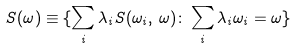Convert formula to latex. <formula><loc_0><loc_0><loc_500><loc_500>S ( \omega ) \equiv \{ \sum _ { i } \lambda _ { i } S ( \omega _ { i } , \, \omega ) \colon \sum _ { i } \lambda _ { i } \omega _ { i } = \omega \}</formula> 